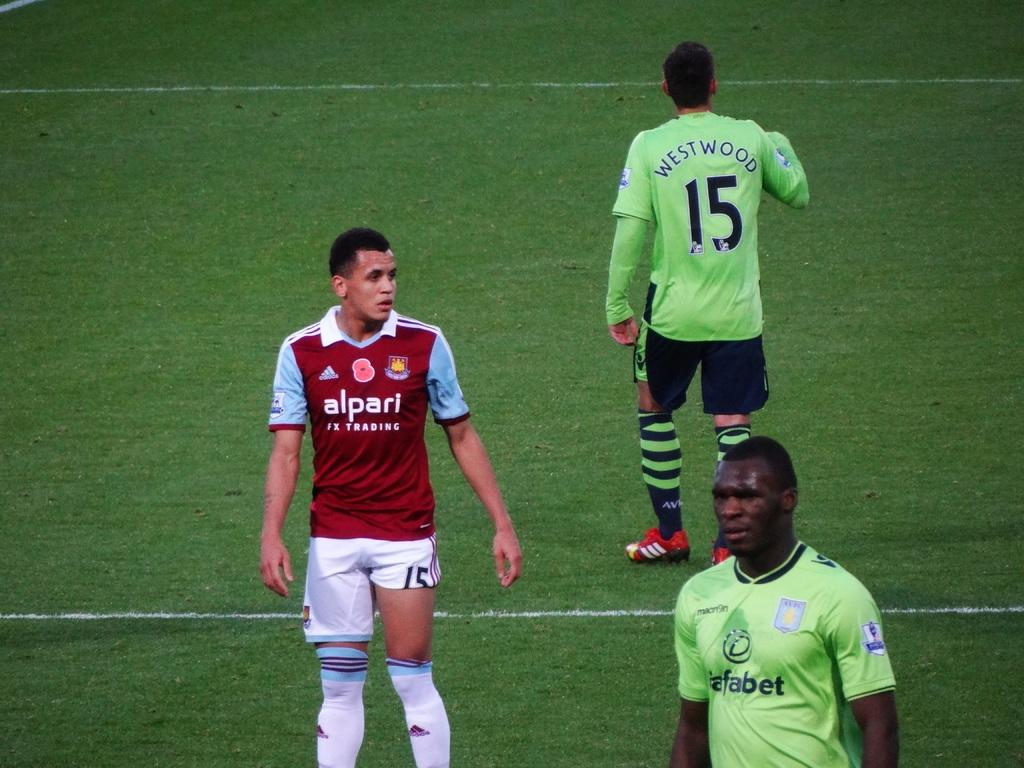<image>
Create a compact narrative representing the image presented. Player number 15, named Westwood, is walking leisurely on the soccer field. 